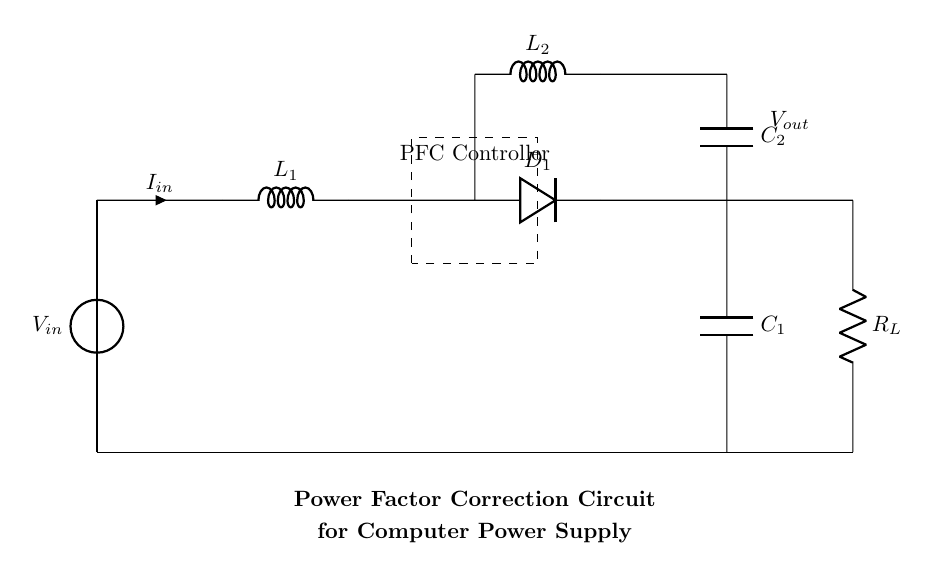What is the input voltage source labeled as? The voltage source is labeled as V_in, indicating it is the input voltage to the circuit.
Answer: V_in What type of component is labeled L1? L1 is labeled as an inductor, which is typically used to store energy in a magnetic field and is a key component in filtering and energy storage.
Answer: Inductor Which components are in parallel in this circuit? The components L2 and C2 are in parallel, as they connect to the same points and share the same voltage across them.
Answer: L2 and C2 What is the purpose of the dashed rectangle in the diagram? The dashed rectangle indicates the presence of a PFC Controller, which actively manages the input and helps improve power factor by controlling energy flow.
Answer: PFC Controller How many capacitors are present in the circuit? There are two capacitors shown in the circuit diagram, labeled as C1 and C2, which are used to filter and smooth the output voltage.
Answer: Two What is the load resistor labeled as? The load resistor in the diagram is labeled as R_L, which typically represents the load that the circuit drives in a power supply system.
Answer: R_L Why is power factor correction important in this circuit? Power factor correction is crucial for improving energy efficiency by minimizing the reactive power in the system, which leads to reduced energy losses and improved performance of high-power appliances.
Answer: Energy efficiency 